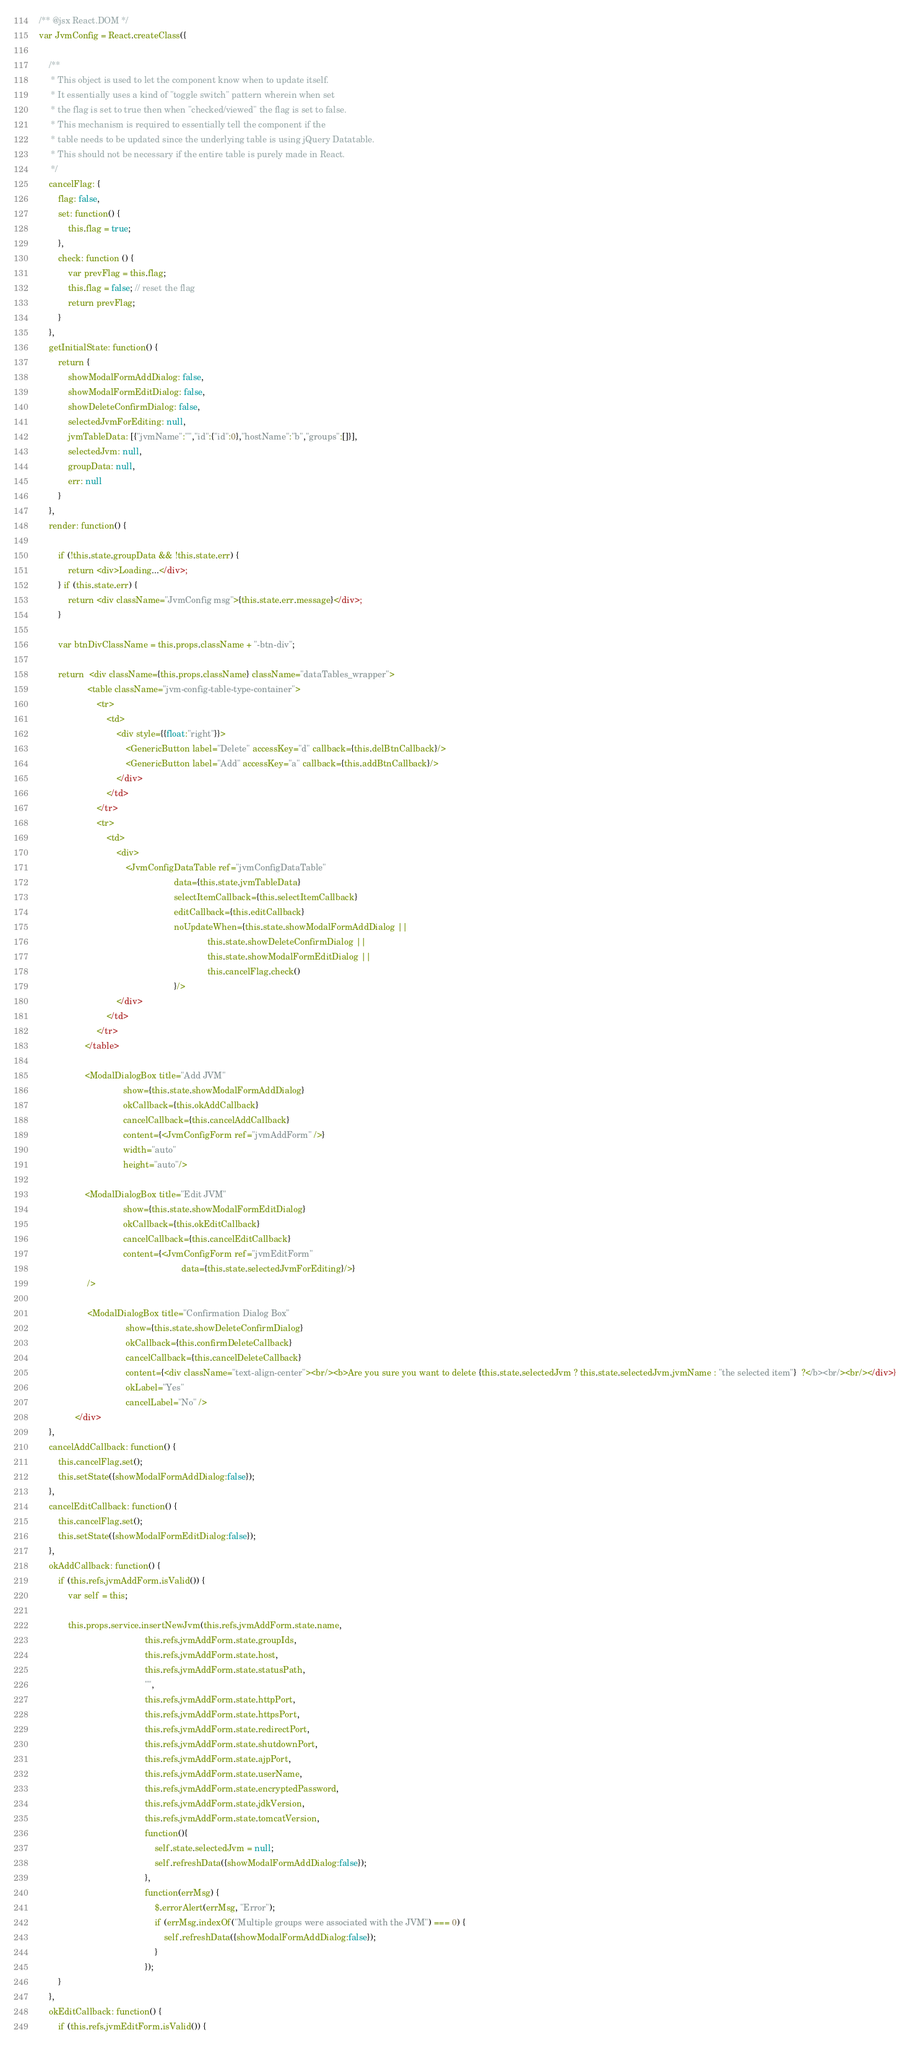Convert code to text. <code><loc_0><loc_0><loc_500><loc_500><_JavaScript_>/** @jsx React.DOM */
var JvmConfig = React.createClass({

    /**
     * This object is used to let the component know when to update itself.
     * It essentially uses a kind of "toggle switch" pattern wherein when set
     * the flag is set to true then when "checked/viewed" the flag is set to false.
     * This mechanism is required to essentially tell the component if the
     * table needs to be updated since the underlying table is using jQuery Datatable.
     * This should not be necessary if the entire table is purely made in React.
     */
    cancelFlag: {
        flag: false,
        set: function() {
            this.flag = true;
        },
        check: function () {
            var prevFlag = this.flag;
            this.flag = false; // reset the flag
            return prevFlag;
        }
    },
    getInitialState: function() {
        return {
            showModalFormAddDialog: false,
            showModalFormEditDialog: false,
            showDeleteConfirmDialog: false,
            selectedJvmForEditing: null,
            jvmTableData: [{"jvmName":"","id":{"id":0},"hostName":"b","groups":[]}],
            selectedJvm: null,
            groupData: null,
            err: null
        }
    },
    render: function() {

        if (!this.state.groupData && !this.state.err) {
            return <div>Loading...</div>;
        } if (this.state.err) {
            return <div className="JvmConfig msg">{this.state.err.message}</div>;
        }

        var btnDivClassName = this.props.className + "-btn-div";

        return  <div className={this.props.className} className="dataTables_wrapper">
                    <table className="jvm-config-table-type-container">
                        <tr>
                            <td>
                                <div style={{float:"right"}}>
                                    <GenericButton label="Delete" accessKey="d" callback={this.delBtnCallback}/>
                                    <GenericButton label="Add" accessKey="a" callback={this.addBtnCallback}/>
                                </div>
                            </td>
                        </tr>
                        <tr>
                            <td>
                                <div>
                                    <JvmConfigDataTable ref="jvmConfigDataTable"
                                                        data={this.state.jvmTableData}
                                                        selectItemCallback={this.selectItemCallback}
                                                        editCallback={this.editCallback}
                                                        noUpdateWhen={this.state.showModalFormAddDialog ||
                                                                      this.state.showDeleteConfirmDialog ||
                                                                      this.state.showModalFormEditDialog ||
                                                                      this.cancelFlag.check()
                                                        }/>
                                </div>
                            </td>
                        </tr>
                   </table>

                   <ModalDialogBox title="Add JVM"
                                   show={this.state.showModalFormAddDialog}
                                   okCallback={this.okAddCallback}
                                   cancelCallback={this.cancelAddCallback}
                                   content={<JvmConfigForm ref="jvmAddForm" />}
                                   width="auto"
                                   height="auto"/>

                   <ModalDialogBox title="Edit JVM"
                                   show={this.state.showModalFormEditDialog}
                                   okCallback={this.okEditCallback}
                                   cancelCallback={this.cancelEditCallback}
                                   content={<JvmConfigForm ref="jvmEditForm"
                                                           data={this.state.selectedJvmForEditing}/>}
                    />

                    <ModalDialogBox title="Confirmation Dialog Box"
                                    show={this.state.showDeleteConfirmDialog}
                                    okCallback={this.confirmDeleteCallback}
                                    cancelCallback={this.cancelDeleteCallback}
                                    content={<div className="text-align-center"><br/><b>Are you sure you want to delete {this.state.selectedJvm ? this.state.selectedJvm.jvmName : "the selected item"}  ?</b><br/><br/></div>}
                                    okLabel="Yes"
                                    cancelLabel="No" />
               </div>
    },
    cancelAddCallback: function() {
        this.cancelFlag.set();
        this.setState({showModalFormAddDialog:false});
    },
    cancelEditCallback: function() {
        this.cancelFlag.set();
        this.setState({showModalFormEditDialog:false});
    },
    okAddCallback: function() {
        if (this.refs.jvmAddForm.isValid()) {
            var self = this;

            this.props.service.insertNewJvm(this.refs.jvmAddForm.state.name,
                                            this.refs.jvmAddForm.state.groupIds,
                                            this.refs.jvmAddForm.state.host,
                                            this.refs.jvmAddForm.state.statusPath,
                                            "",
                                            this.refs.jvmAddForm.state.httpPort,
                                            this.refs.jvmAddForm.state.httpsPort,
                                            this.refs.jvmAddForm.state.redirectPort,
                                            this.refs.jvmAddForm.state.shutdownPort,
                                            this.refs.jvmAddForm.state.ajpPort,
                                            this.refs.jvmAddForm.state.userName,
                                            this.refs.jvmAddForm.state.encryptedPassword,
                                            this.refs.jvmAddForm.state.jdkVersion,
                                            this.refs.jvmAddForm.state.tomcatVersion,
                                            function(){
                                                self.state.selectedJvm = null;
                                                self.refreshData({showModalFormAddDialog:false});
                                            },
                                            function(errMsg) {
                                                $.errorAlert(errMsg, "Error");
                                                if (errMsg.indexOf("Multiple groups were associated with the JVM") === 0) {
                                                    self.refreshData({showModalFormAddDialog:false});
                                                }
                                            });
        }
    },
    okEditCallback: function() {
        if (this.refs.jvmEditForm.isValid()) {</code> 